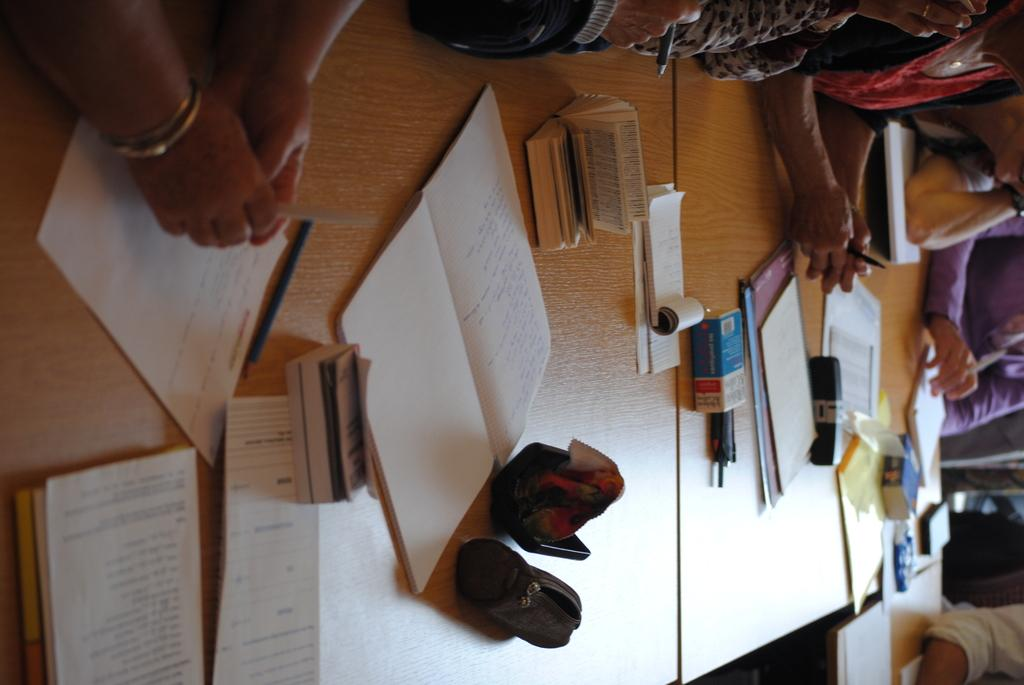How many people are in the group visible in the image? There is a group of people in the image, but the exact number cannot be determined from the provided facts. What is located in front of the group of people? There are tables in front of the group of people. What items can be seen on the tables? There are books, papers, and boxes on the tables. What type of cabbage is being used as a table decoration in the image? There is no cabbage present in the image, so it cannot be used as a table decoration. 